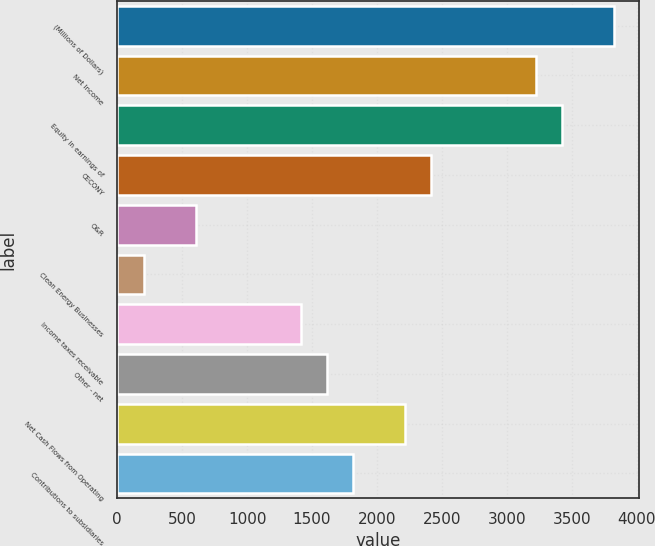<chart> <loc_0><loc_0><loc_500><loc_500><bar_chart><fcel>(Millions of Dollars)<fcel>Net Income<fcel>Equity in earnings of<fcel>CECONY<fcel>O&R<fcel>Clean Energy Businesses<fcel>Income taxes receivable<fcel>Other - net<fcel>Net Cash Flows from Operating<fcel>Contributions to subsidiaries<nl><fcel>3828.6<fcel>3224.4<fcel>3425.8<fcel>2418.8<fcel>606.2<fcel>203.4<fcel>1411.8<fcel>1613.2<fcel>2217.4<fcel>1814.6<nl></chart> 